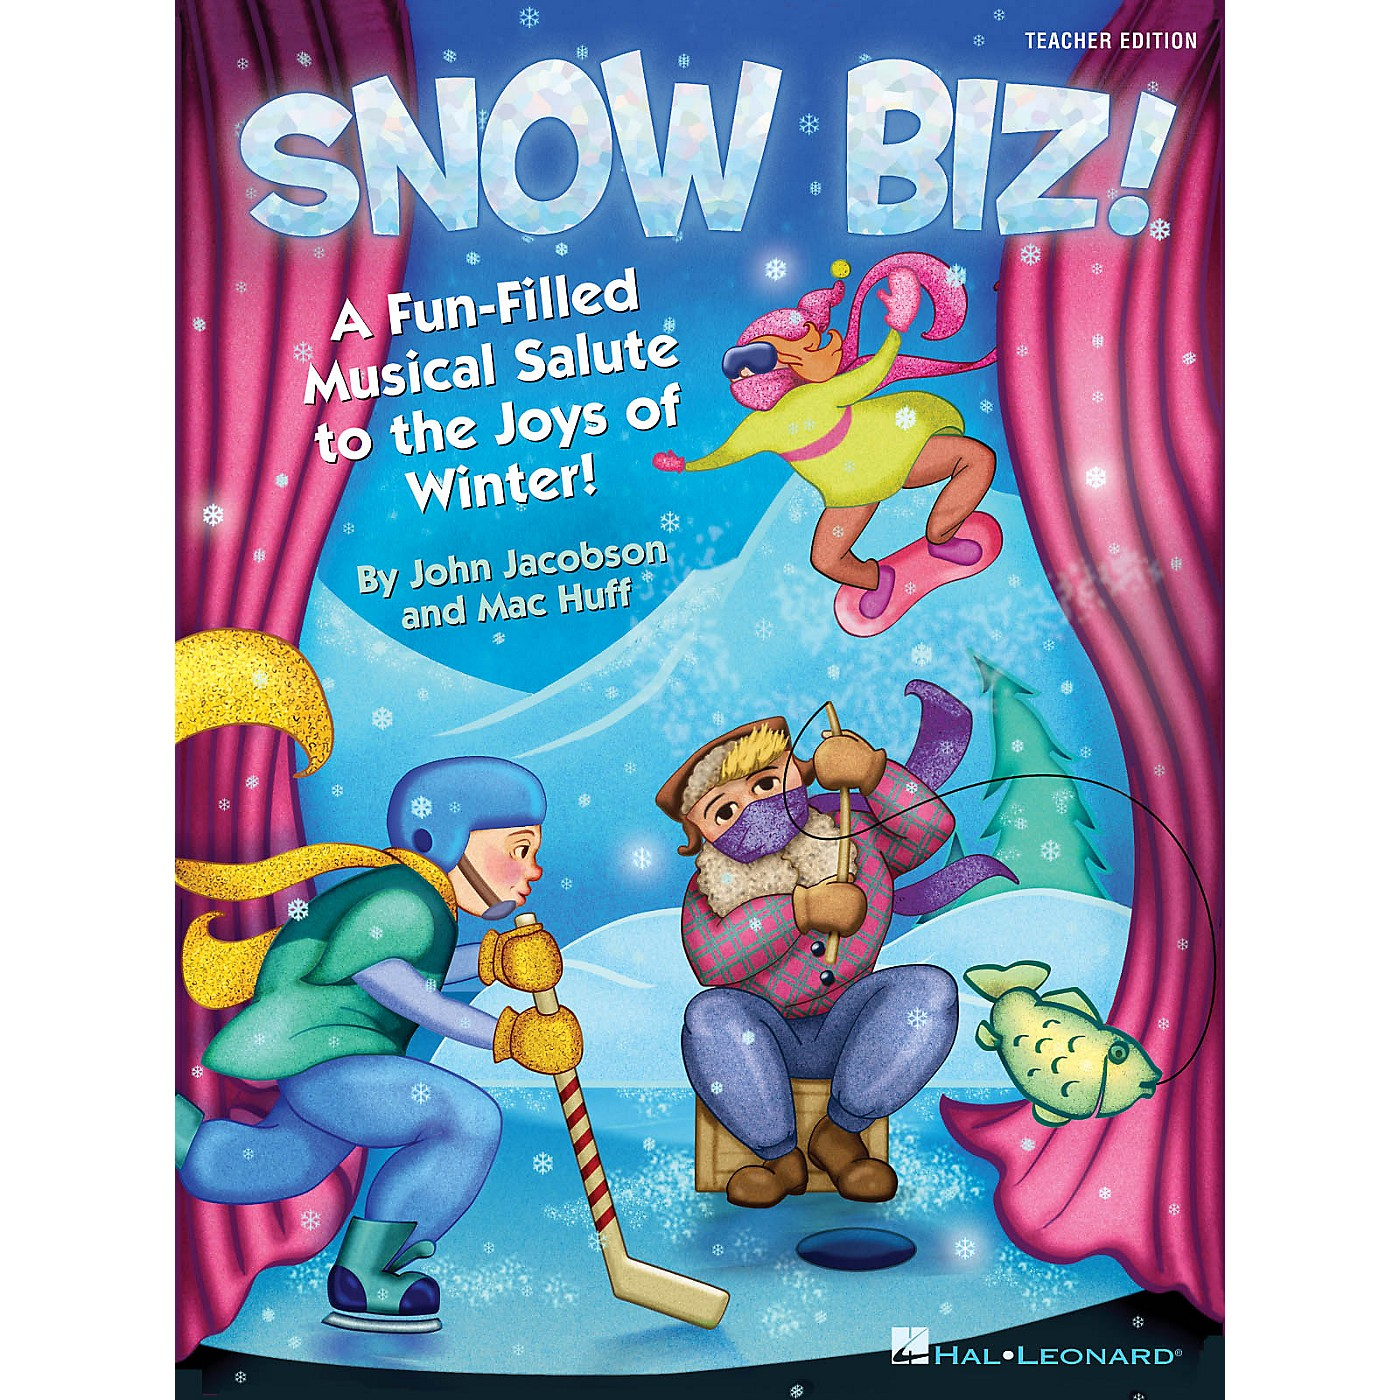How would you describe this material to someone who cannot see it? This material, titled 'SNOW BIZ!,' is a vibrant and engaging children's book or theatrical piece that celebrates the fun and beauty of winter. The cover features colorful, cartoon-style illustrations of children engaging in various winter activities against a backdrop of snowy scenery. One child is joyfully playing hockey, another is sitting and ice fishing, and a third character is leaping through the air excitedly. The playful scene is filled with bright colors and whimsical elements, including a humorous creature in summer attire who adds to the fun. This lively depiction is further enhanced by the title and subtitle, which promise a musical salute to the joys of winter, suggesting that the material contains songs, stories, and activities designed to entertain and educate young audiences about the season's delights. 